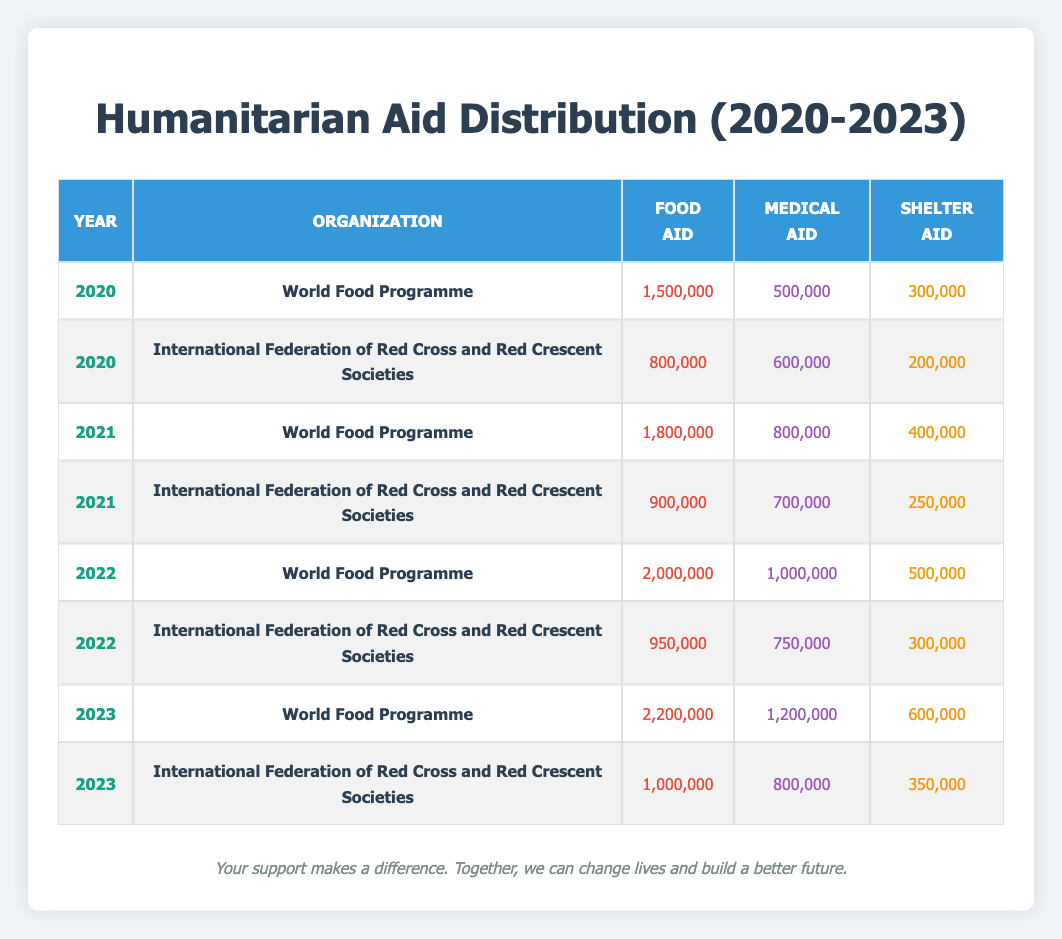What is the total amount of food aid distributed by the World Food Programme in 2020? According to the table, the World Food Programme distributed 1,500,000 in food aid in 2020.
Answer: 1,500,000 What year did the International Federation of Red Cross and Red Crescent Societies provide the least amount of shelter aid? Looking at the table, the least amount of shelter aid provided by this organization was 200,000 in 2020.
Answer: 200,000 How much more medical aid did the World Food Programme provide in 2023 compared to 2021? The World Food Programme provided 1,200,000 in medical aid in 2023, and 800,000 in 2021. The difference is 1,200,000 - 800,000 = 400,000.
Answer: 400,000 Did the total food aid from the World Food Programme increase every year from 2020 to 2023? By examining the food aid amounts per year (1,500,000 in 2020, 1,800,000 in 2021, 2,000,000 in 2022, and 2,200,000 in 2023), we see that it increased each year.
Answer: Yes What is the average shelter aid provided by both organizations in 2022? In 2022, the World Food Programme provided 500,000 and the International Federation of Red Cross and Red Crescent Societies provided 300,000 in shelter aid. The total is 500,000 + 300,000 = 800,000, and dividing this by 2 gives an average of 400,000.
Answer: 400,000 Which organization provided the highest total amount of medical aid across the years 2020 to 2023? To find this, we can calculate the total medical aid provided by each organization: World Food Programme: 500,000 + 800,000 + 1,000,000 + 1,200,000 = 3,500,000; International Federation of Red Cross and Red Crescent Societies: 600,000 + 700,000 + 750,000 + 800,000 = 2,850,000. The World Food Programme provided the highest total.
Answer: World Food Programme How much total humanitarian aid did the International Federation of Red Cross and Red Crescent Societies distribute in 2021? In 2021, this organization distributed 900,000 in food aid, 700,000 in medical aid, and 250,000 in shelter aid. Summing these gives a total of 900,000 + 700,000 + 250,000 = 1,850,000.
Answer: 1,850,000 Is the total amount of food aid provided by International Federation of Red Cross and Red Crescent Societies greater than 1,000,000 in 2022? In 2022, this organization provided 950,000 in food aid, which is less than 1,000,000.
Answer: No 